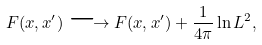<formula> <loc_0><loc_0><loc_500><loc_500>F ( x , x ^ { \prime } ) \longrightarrow F ( x , x ^ { \prime } ) + \frac { 1 } { 4 \pi } \ln L ^ { 2 } ,</formula> 